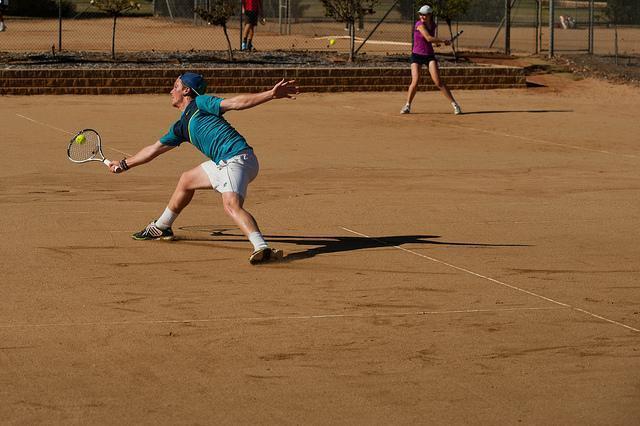How many people are on the other team?
Give a very brief answer. 2. How many people can be seen?
Give a very brief answer. 2. 